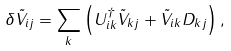Convert formula to latex. <formula><loc_0><loc_0><loc_500><loc_500>\delta \tilde { V } _ { i j } = \sum _ { k } \left ( U _ { i k } ^ { \dagger } \tilde { V } _ { k j } + \tilde { V } _ { i k } D _ { k j } \right ) ,</formula> 